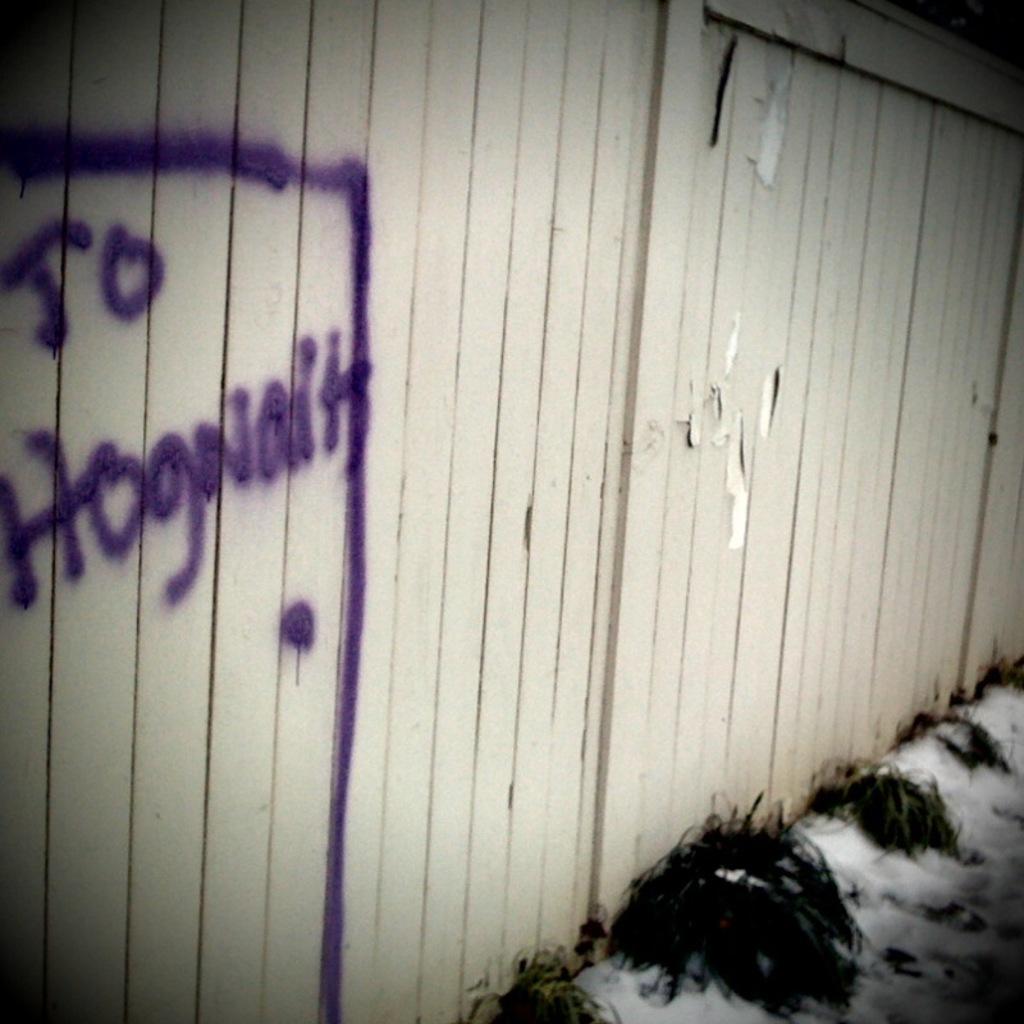Could you give a brief overview of what you see in this image? In this image we can see plants, ice on the road and wooden fence on which we can see some text written which is violet in color. 